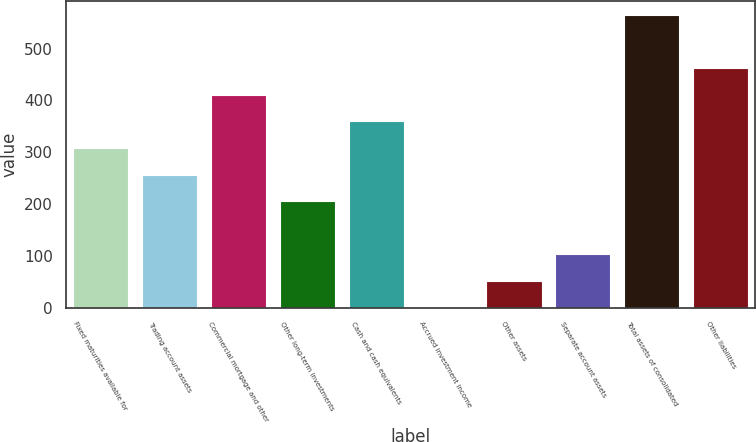Convert chart. <chart><loc_0><loc_0><loc_500><loc_500><bar_chart><fcel>Fixed maturities available for<fcel>Trading account assets<fcel>Commercial mortgage and other<fcel>Other long-term investments<fcel>Cash and cash equivalents<fcel>Accrued investment income<fcel>Other assets<fcel>Separate account assets<fcel>Total assets of consolidated<fcel>Other liabilities<nl><fcel>308.2<fcel>257<fcel>410.6<fcel>205.8<fcel>359.4<fcel>1<fcel>52.2<fcel>103.4<fcel>564.2<fcel>461.8<nl></chart> 